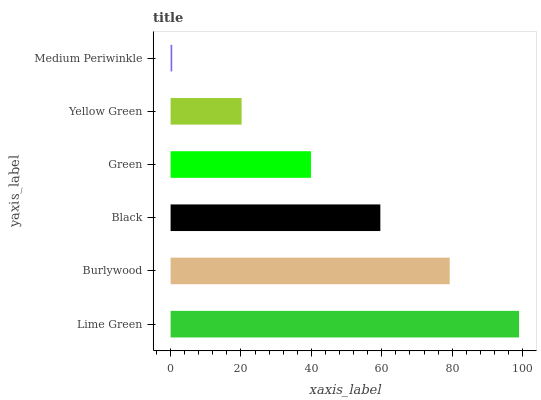Is Medium Periwinkle the minimum?
Answer yes or no. Yes. Is Lime Green the maximum?
Answer yes or no. Yes. Is Burlywood the minimum?
Answer yes or no. No. Is Burlywood the maximum?
Answer yes or no. No. Is Lime Green greater than Burlywood?
Answer yes or no. Yes. Is Burlywood less than Lime Green?
Answer yes or no. Yes. Is Burlywood greater than Lime Green?
Answer yes or no. No. Is Lime Green less than Burlywood?
Answer yes or no. No. Is Black the high median?
Answer yes or no. Yes. Is Green the low median?
Answer yes or no. Yes. Is Medium Periwinkle the high median?
Answer yes or no. No. Is Burlywood the low median?
Answer yes or no. No. 